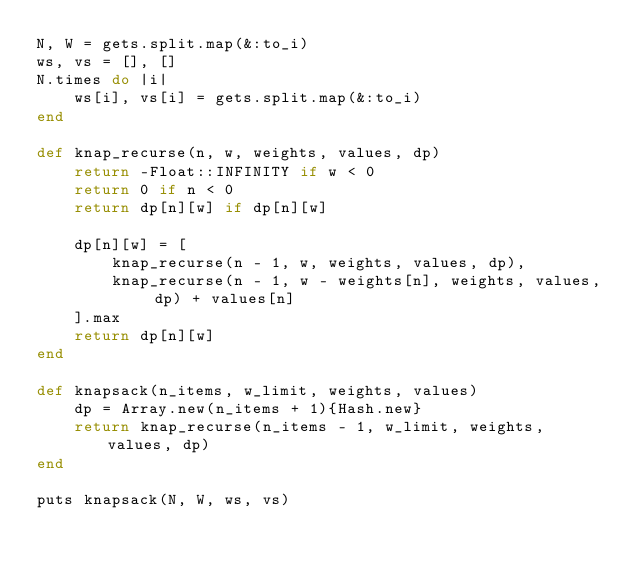<code> <loc_0><loc_0><loc_500><loc_500><_Ruby_>N, W = gets.split.map(&:to_i)
ws, vs = [], []
N.times do |i|
    ws[i], vs[i] = gets.split.map(&:to_i)
end

def knap_recurse(n, w, weights, values, dp)
    return -Float::INFINITY if w < 0
    return 0 if n < 0
    return dp[n][w] if dp[n][w]

    dp[n][w] = [
        knap_recurse(n - 1, w, weights, values, dp),
        knap_recurse(n - 1, w - weights[n], weights, values, dp) + values[n]
    ].max
    return dp[n][w]
end

def knapsack(n_items, w_limit, weights, values)
    dp = Array.new(n_items + 1){Hash.new}
    return knap_recurse(n_items - 1, w_limit, weights, values, dp)
end

puts knapsack(N, W, ws, vs)</code> 